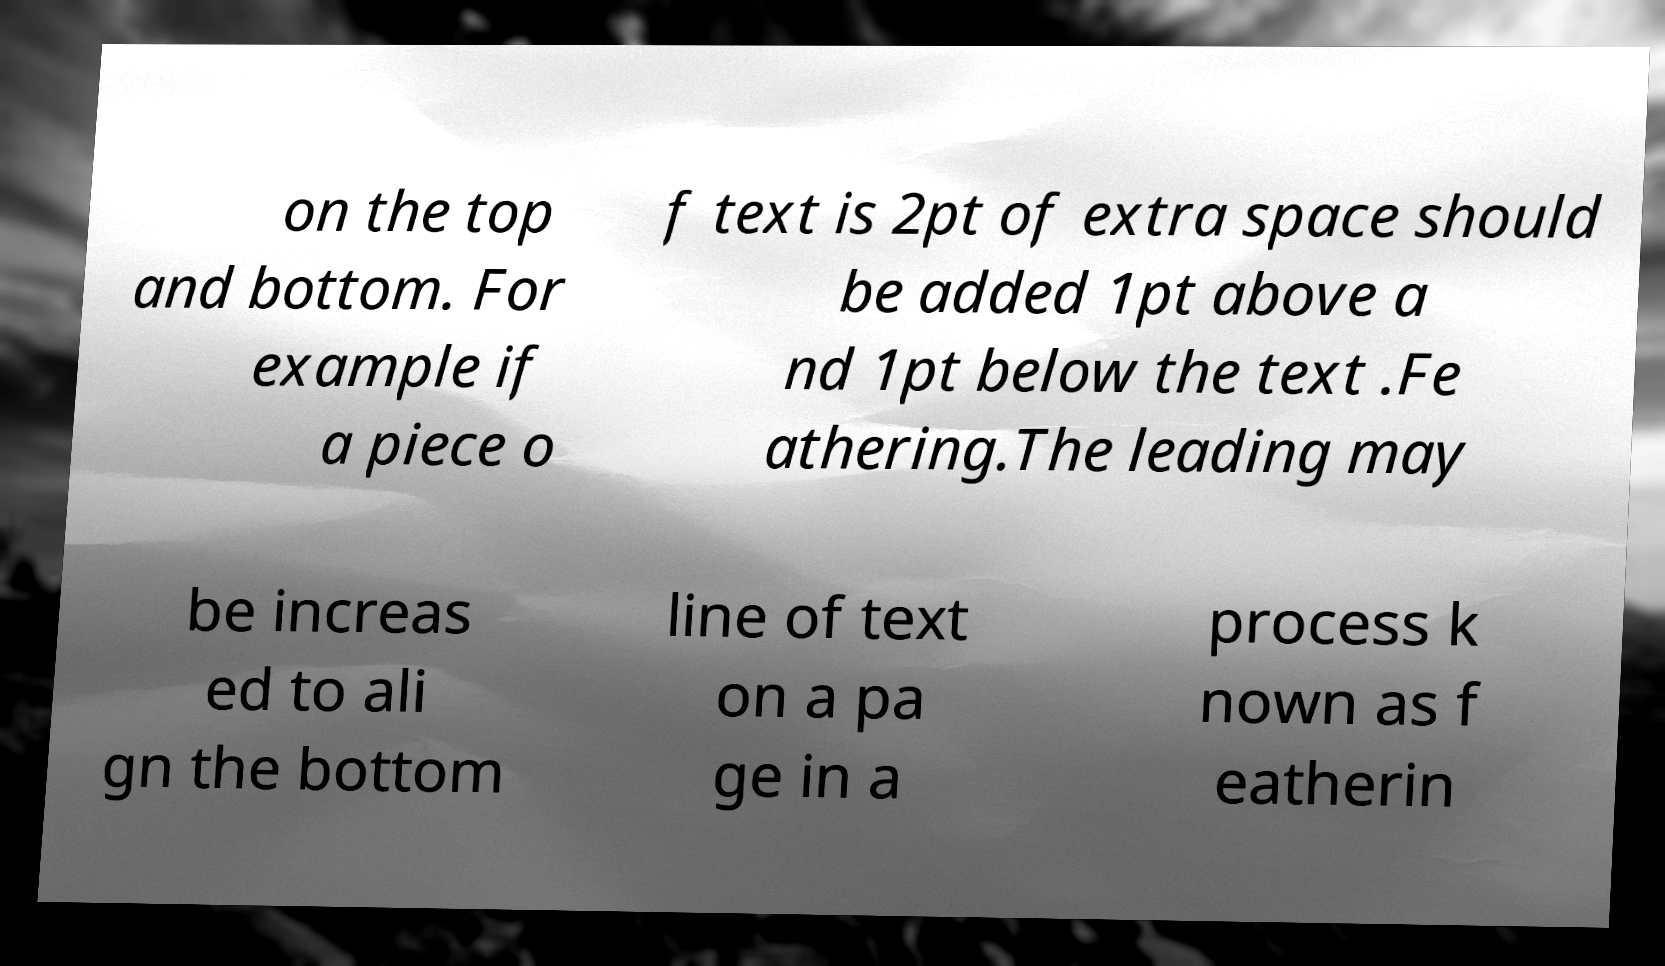Could you extract and type out the text from this image? on the top and bottom. For example if a piece o f text is 2pt of extra space should be added 1pt above a nd 1pt below the text .Fe athering.The leading may be increas ed to ali gn the bottom line of text on a pa ge in a process k nown as f eatherin 